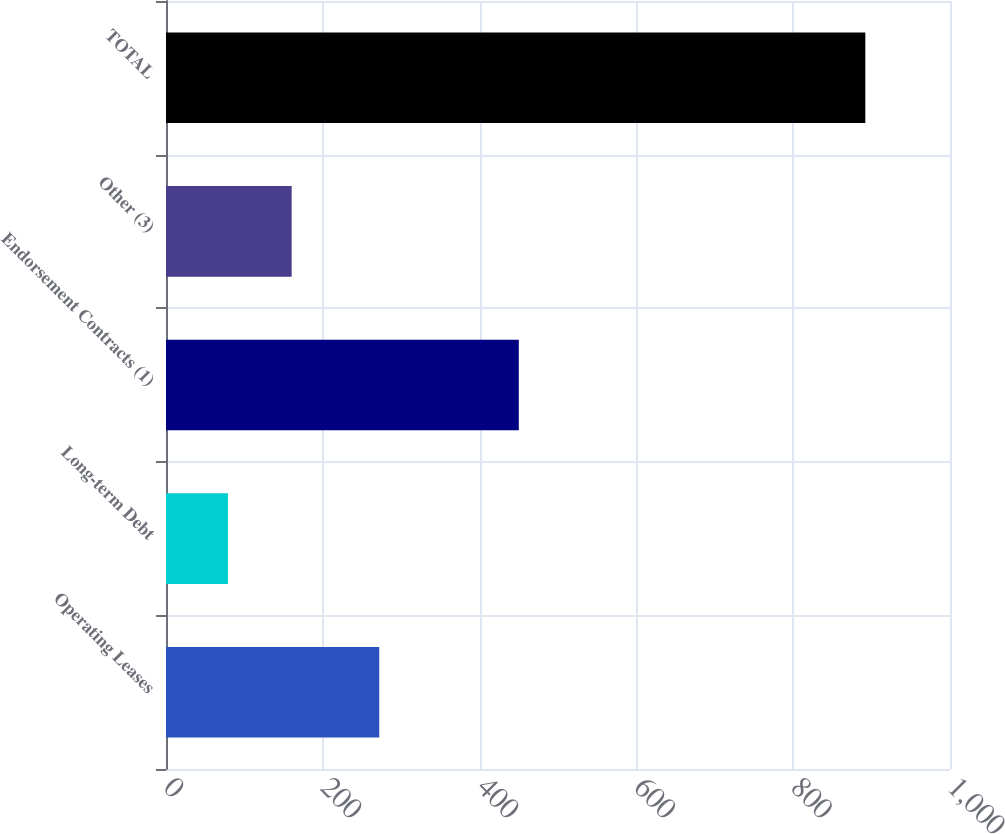Convert chart to OTSL. <chart><loc_0><loc_0><loc_500><loc_500><bar_chart><fcel>Operating Leases<fcel>Long-term Debt<fcel>Endorsement Contracts (1)<fcel>Other (3)<fcel>TOTAL<nl><fcel>272<fcel>79<fcel>450<fcel>160.3<fcel>892<nl></chart> 